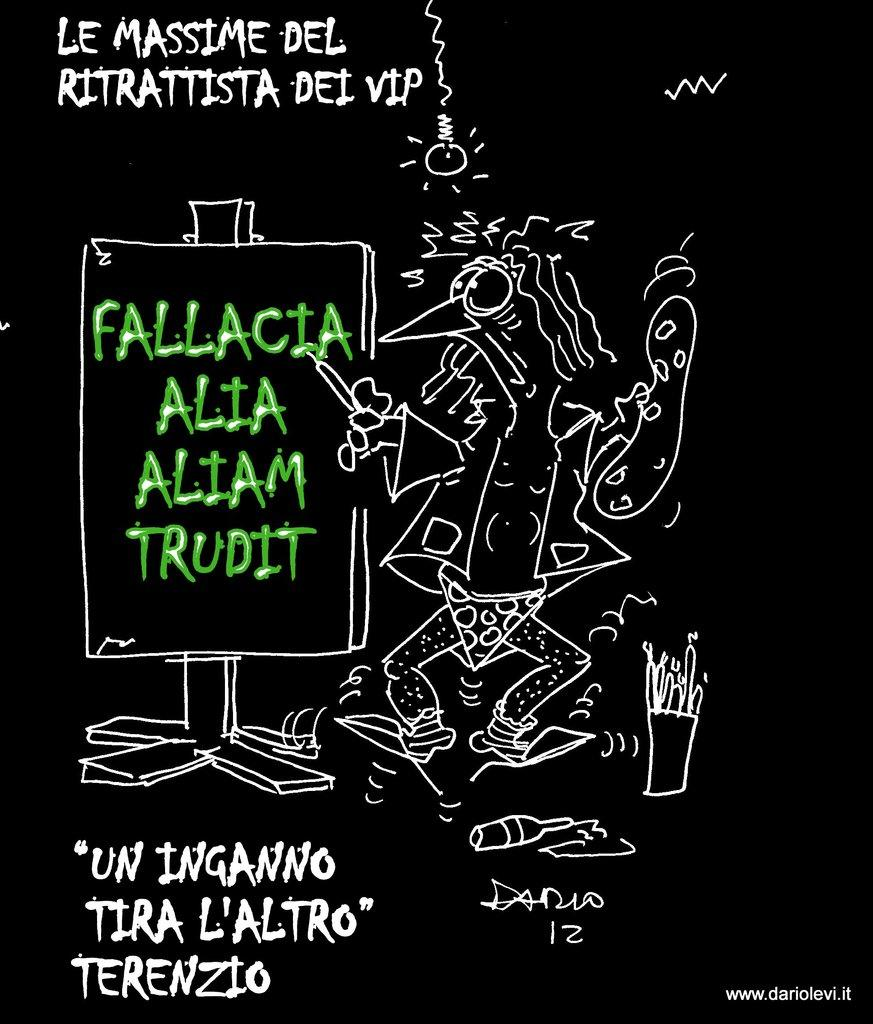<image>
Render a clear and concise summary of the photo. Someone drew a chicken in their underwear that reads le massime del ritrattista dei vip. 